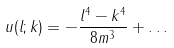Convert formula to latex. <formula><loc_0><loc_0><loc_500><loc_500>u ( l ; k ) = - \frac { l ^ { 4 } - k ^ { 4 } } { 8 m ^ { 3 } } + \dots</formula> 